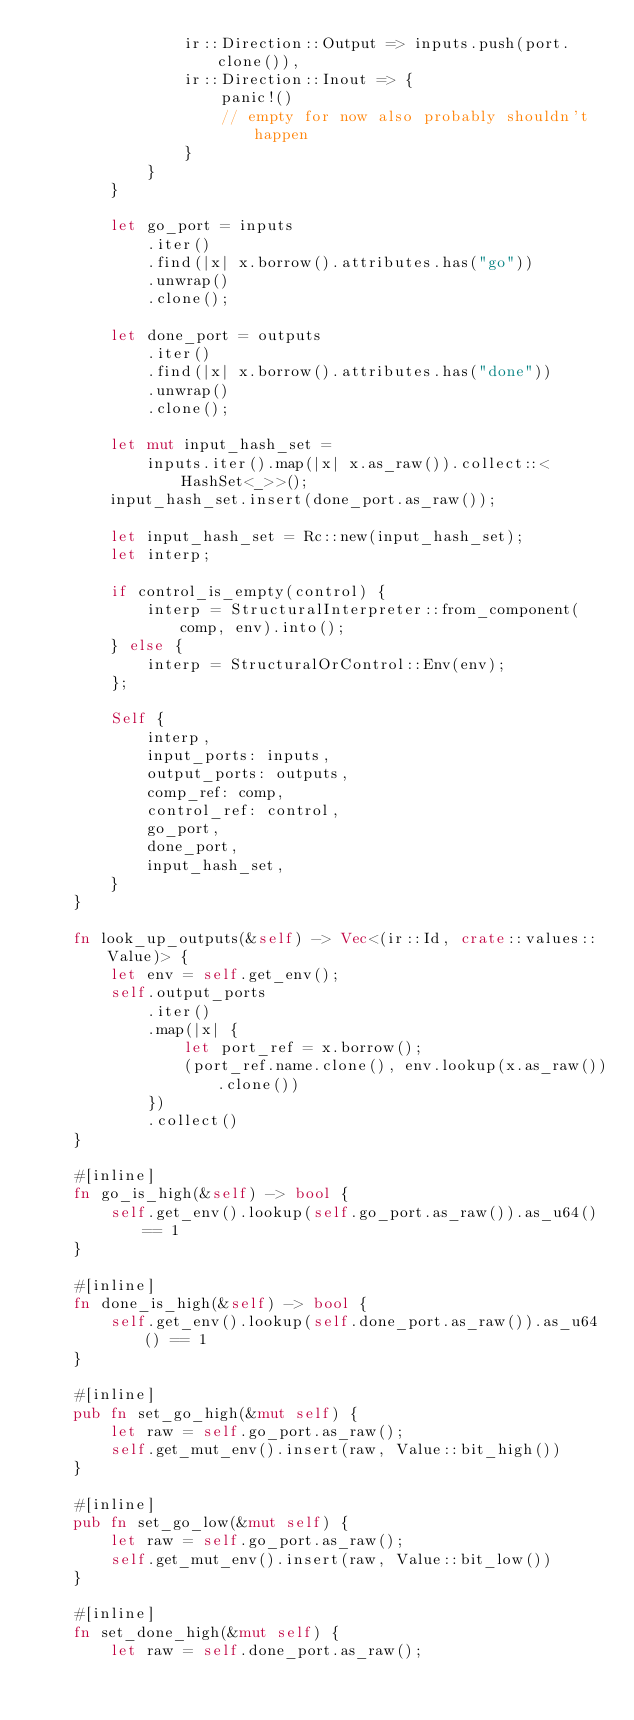<code> <loc_0><loc_0><loc_500><loc_500><_Rust_>                ir::Direction::Output => inputs.push(port.clone()),
                ir::Direction::Inout => {
                    panic!()
                    // empty for now also probably shouldn't happen
                }
            }
        }

        let go_port = inputs
            .iter()
            .find(|x| x.borrow().attributes.has("go"))
            .unwrap()
            .clone();

        let done_port = outputs
            .iter()
            .find(|x| x.borrow().attributes.has("done"))
            .unwrap()
            .clone();

        let mut input_hash_set =
            inputs.iter().map(|x| x.as_raw()).collect::<HashSet<_>>();
        input_hash_set.insert(done_port.as_raw());

        let input_hash_set = Rc::new(input_hash_set);
        let interp;

        if control_is_empty(control) {
            interp = StructuralInterpreter::from_component(comp, env).into();
        } else {
            interp = StructuralOrControl::Env(env);
        };

        Self {
            interp,
            input_ports: inputs,
            output_ports: outputs,
            comp_ref: comp,
            control_ref: control,
            go_port,
            done_port,
            input_hash_set,
        }
    }

    fn look_up_outputs(&self) -> Vec<(ir::Id, crate::values::Value)> {
        let env = self.get_env();
        self.output_ports
            .iter()
            .map(|x| {
                let port_ref = x.borrow();
                (port_ref.name.clone(), env.lookup(x.as_raw()).clone())
            })
            .collect()
    }

    #[inline]
    fn go_is_high(&self) -> bool {
        self.get_env().lookup(self.go_port.as_raw()).as_u64() == 1
    }

    #[inline]
    fn done_is_high(&self) -> bool {
        self.get_env().lookup(self.done_port.as_raw()).as_u64() == 1
    }

    #[inline]
    pub fn set_go_high(&mut self) {
        let raw = self.go_port.as_raw();
        self.get_mut_env().insert(raw, Value::bit_high())
    }

    #[inline]
    pub fn set_go_low(&mut self) {
        let raw = self.go_port.as_raw();
        self.get_mut_env().insert(raw, Value::bit_low())
    }

    #[inline]
    fn set_done_high(&mut self) {
        let raw = self.done_port.as_raw();</code> 